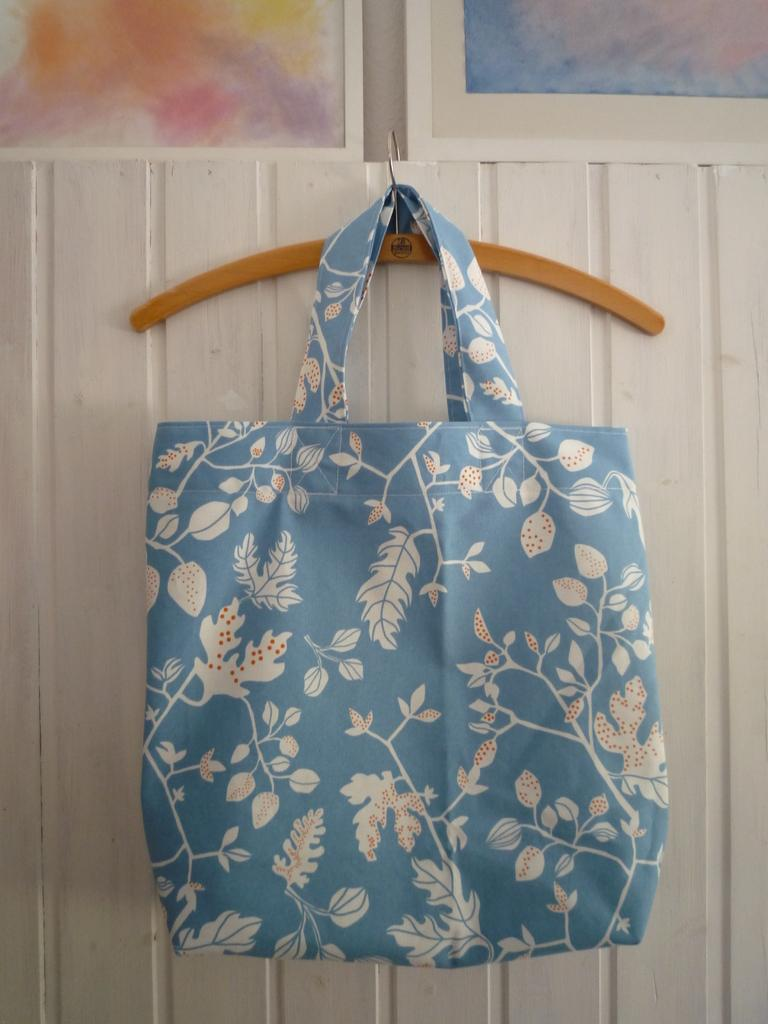What is hanging on the hanger in the image? There is a bag hanging on a hanger in the image. What can be seen in the background of the image? There are frames visible in the background, and there is also a wall. What type of bread is being offered by the crook in the image? There is no crook or bread present in the image. 